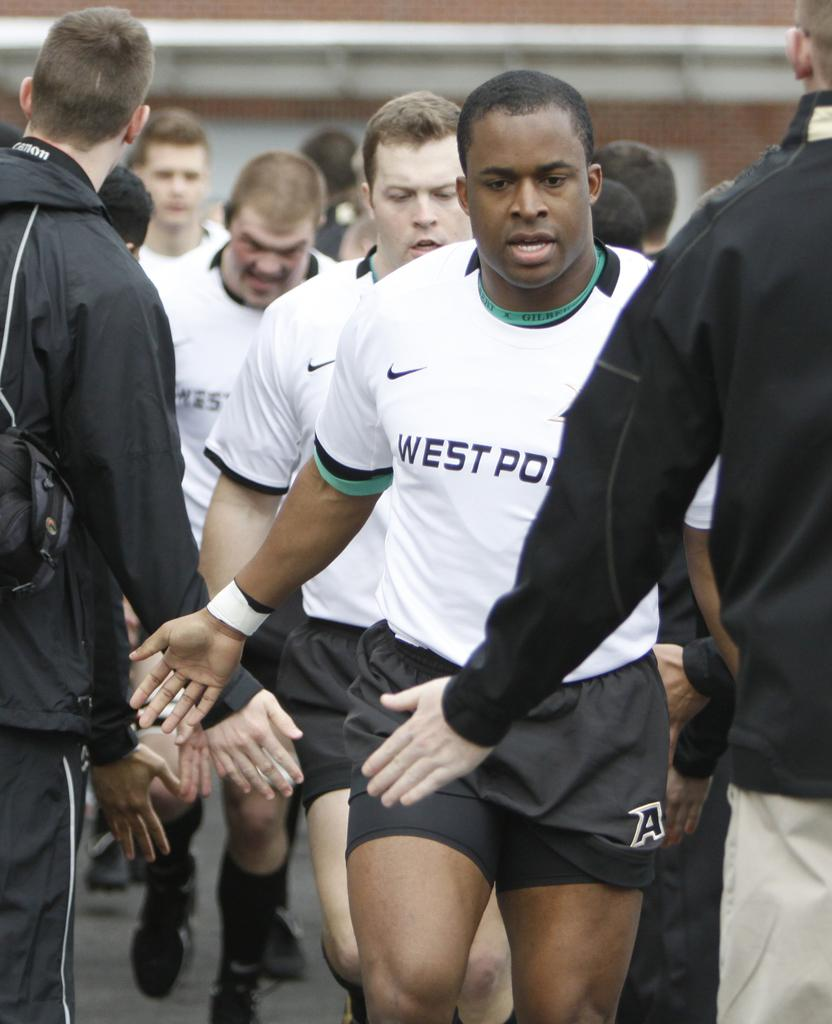What are the people in the image doing? There are people walking, standing, and clapping their hands in the image. How are the people interacting with each other? The people are interacting with each other, as some are clapping their hands. Can you describe the actions of the people in the image? The people are walking, standing, and clapping their hands, indicating that they might be participating in or observing an event. Reasoning: Let' Let's think step by step in order to produce the conversation. We start by identifying the main subjects in the image, which are the people. Then, we describe their actions and interactions based on the provided facts. We avoid yes/no questions and ensure that the language is simple and clear. Absurd Question/Answer: What type of pickle can be seen hanging from the sheet in the image? There is no pickle or sheet present in the image; it only features people walking, standing, and clapping their hands. What type of pickle can be seen hanging from the sheet in the image? There is no pickle or sheet present in the image; it only features people walking, standing, and clapping their hands. 